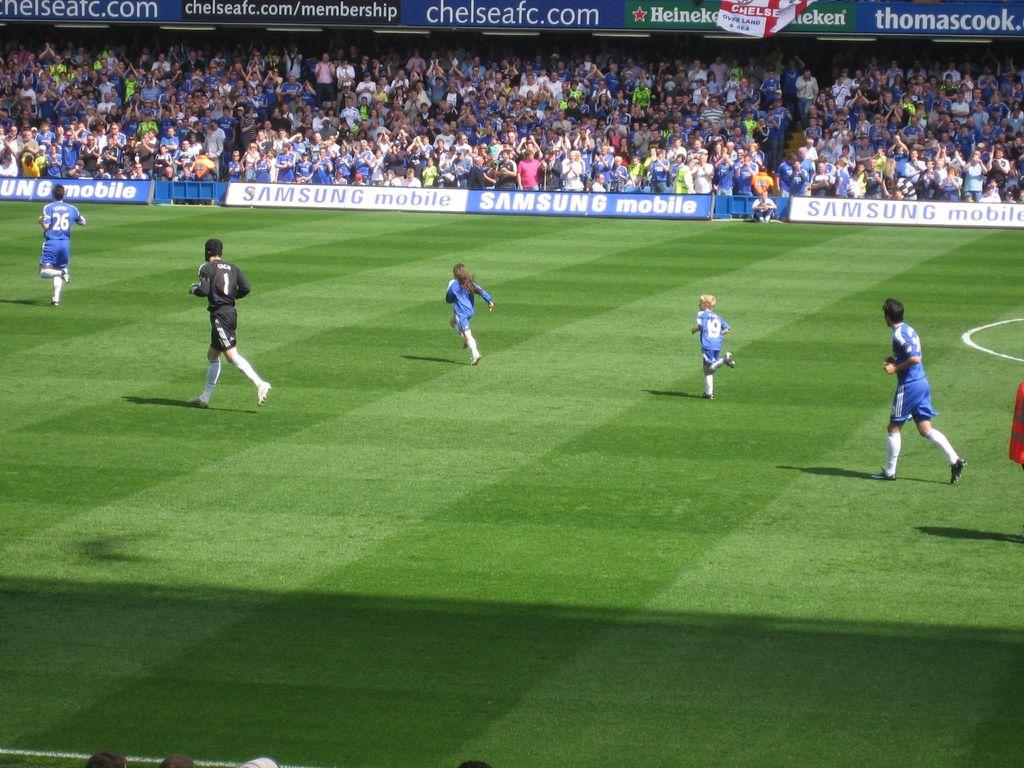What number is the player in the light blue?
Offer a very short reply. 26. What number is the player in dark blue?
Make the answer very short. 1. 